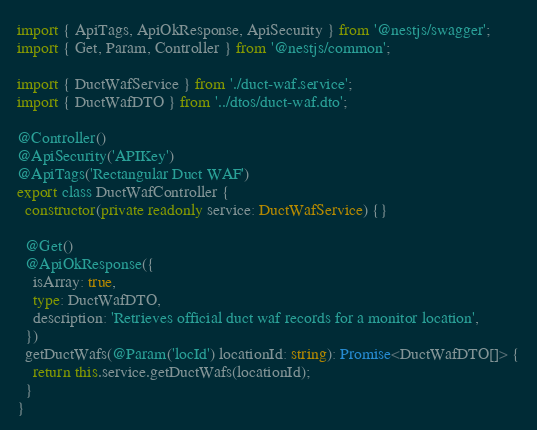Convert code to text. <code><loc_0><loc_0><loc_500><loc_500><_TypeScript_>import { ApiTags, ApiOkResponse, ApiSecurity } from '@nestjs/swagger';
import { Get, Param, Controller } from '@nestjs/common';

import { DuctWafService } from './duct-waf.service';
import { DuctWafDTO } from '../dtos/duct-waf.dto';

@Controller()
@ApiSecurity('APIKey')
@ApiTags('Rectangular Duct WAF')
export class DuctWafController {
  constructor(private readonly service: DuctWafService) {}

  @Get()
  @ApiOkResponse({
    isArray: true,
    type: DuctWafDTO,
    description: 'Retrieves official duct waf records for a monitor location',
  })
  getDuctWafs(@Param('locId') locationId: string): Promise<DuctWafDTO[]> {
    return this.service.getDuctWafs(locationId);
  }
}
</code> 